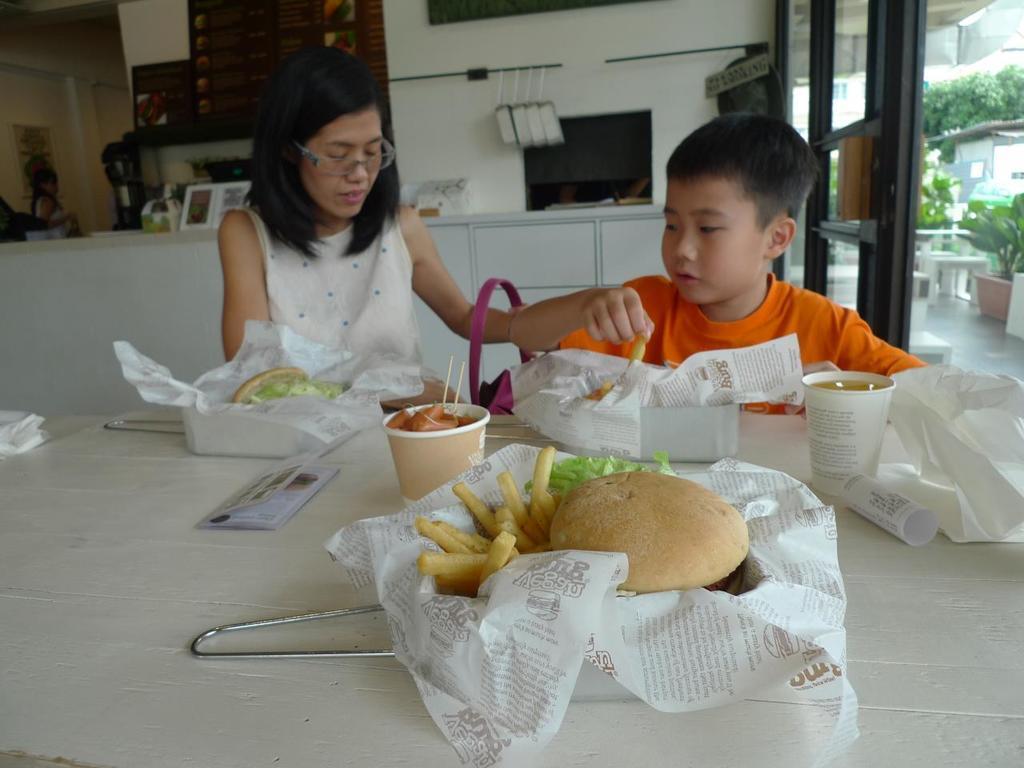Please provide a concise description of this image. Here in this picture we can see a woman and a child sitting on chairs with table in front of them having boxes of burgers and french fries and we can also see other food items all present on the table and behind them we can see a counter and we can also see some things present on it and on the right side we can see plants and trees present outside and we can also see tables and chairs also present. 